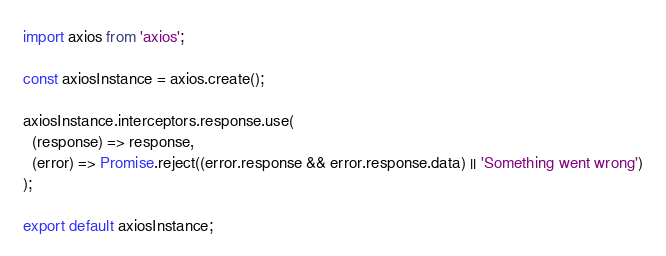Convert code to text. <code><loc_0><loc_0><loc_500><loc_500><_JavaScript_>import axios from 'axios';

const axiosInstance = axios.create();

axiosInstance.interceptors.response.use(
  (response) => response,
  (error) => Promise.reject((error.response && error.response.data) || 'Something went wrong')
);

export default axiosInstance;
</code> 